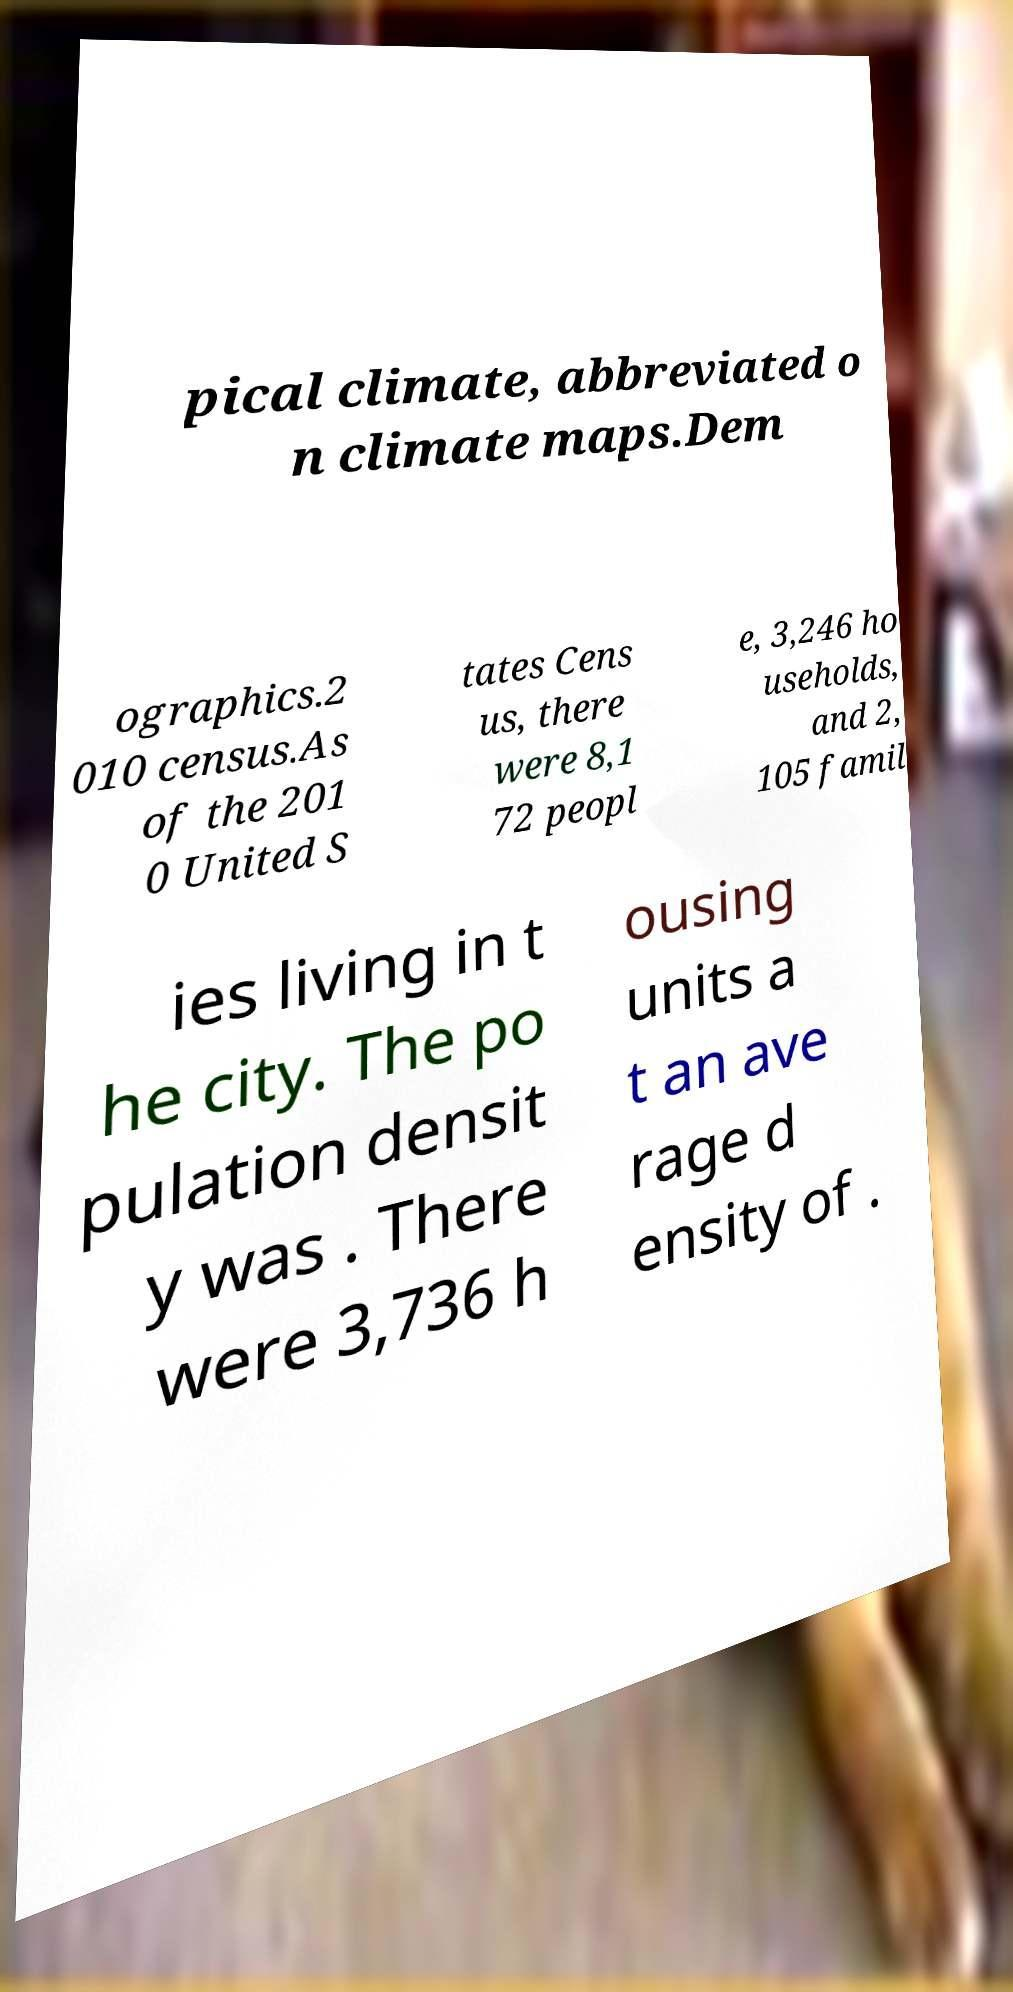Please read and relay the text visible in this image. What does it say? pical climate, abbreviated o n climate maps.Dem ographics.2 010 census.As of the 201 0 United S tates Cens us, there were 8,1 72 peopl e, 3,246 ho useholds, and 2, 105 famil ies living in t he city. The po pulation densit y was . There were 3,736 h ousing units a t an ave rage d ensity of . 